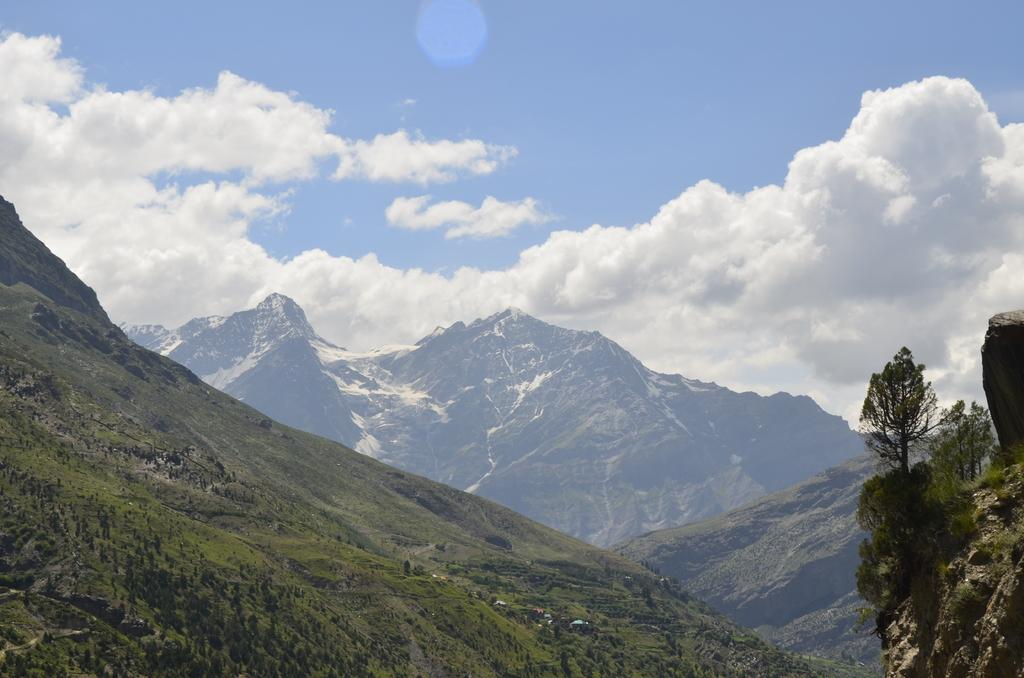What type of natural formation can be seen in the image? There are mountains in the image. What type of vegetation is present in the image? There are trees in the image. What is visible at the top of the image? The sky is visible at the top of the image. How many parents can be seen interacting with the cattle in the image? There are no parents or cattle present in the image; it features mountains and trees. What type of weather condition is depicted by the mist in the image? There is no mist present in the image; it only features mountains, trees, and the sky. 